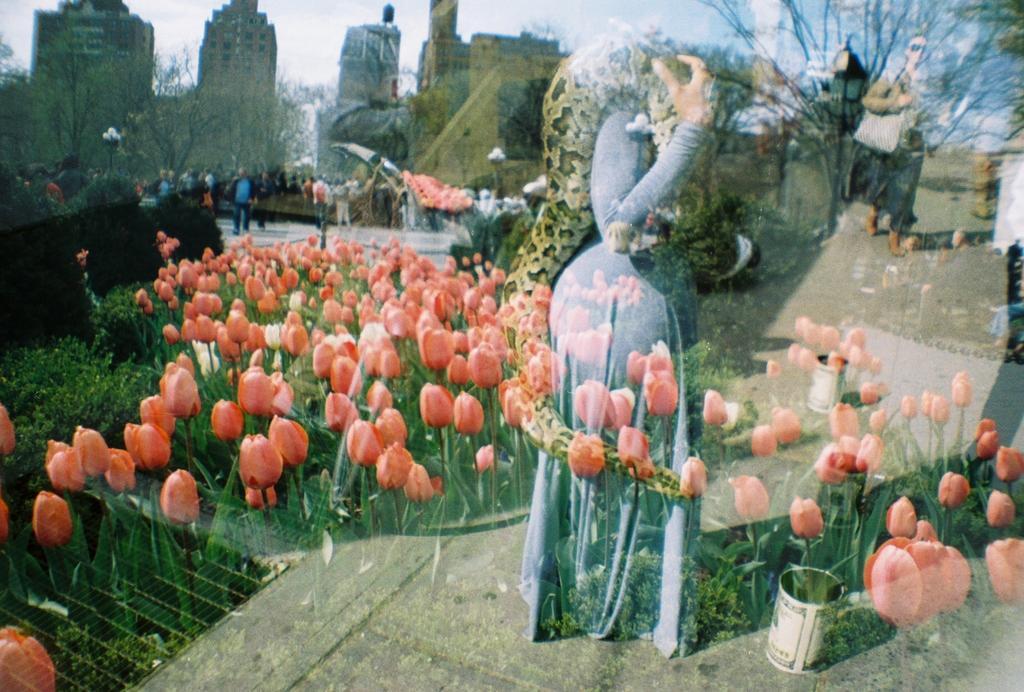Could you give a brief overview of what you see in this image? In this image we can see women standing on the road, buildings, trees, persons, street poles, street lights, plants, flowers, bins and sky. 